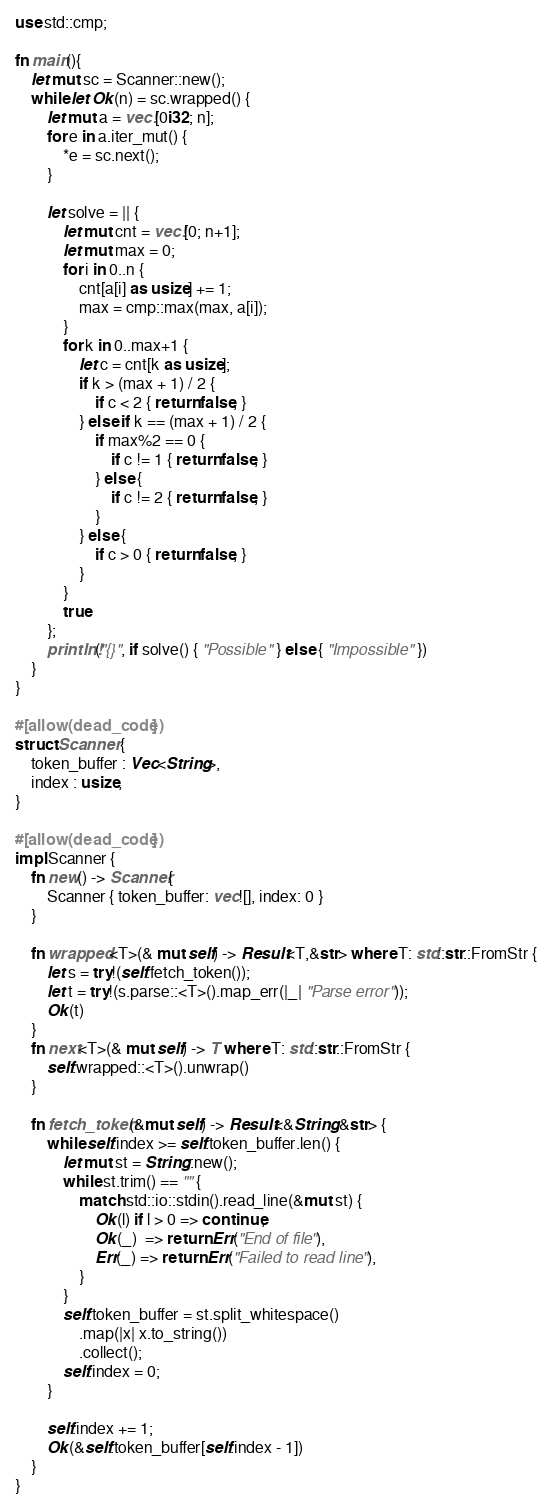<code> <loc_0><loc_0><loc_500><loc_500><_Rust_>use std::cmp;

fn main(){
    let mut sc = Scanner::new();
    while let Ok(n) = sc.wrapped() {
        let mut a = vec![0i32; n];
        for e in a.iter_mut() {
            *e = sc.next();
        }

        let solve = || {
            let mut cnt = vec![0; n+1];
            let mut max = 0;
            for i in 0..n {
                cnt[a[i] as usize] += 1;
                max = cmp::max(max, a[i]);
            }
            for k in 0..max+1 {
                let c = cnt[k as usize];
                if k > (max + 1) / 2 {
                    if c < 2 { return false; }
                } else if k == (max + 1) / 2 {
                    if max%2 == 0 {
                        if c != 1 { return false; }
                    } else {
                        if c != 2 { return false; }
                    }
                } else {
                    if c > 0 { return false; }
                }
            }
            true
        };
        println!("{}", if solve() { "Possible" } else { "Impossible" })
    }
}

#[allow(dead_code)]
struct Scanner {
    token_buffer : Vec<String>,
    index : usize,
}

#[allow(dead_code)]
impl Scanner {
    fn new() -> Scanner{
        Scanner { token_buffer: vec![], index: 0 }
    }

    fn wrapped<T>(& mut self) -> Result<T,&str> where T: std::str::FromStr {
        let s = try!(self.fetch_token());
        let t = try!(s.parse::<T>().map_err(|_| "Parse error"));
        Ok(t)
    }
    fn next<T>(& mut self) -> T where T: std::str::FromStr {
        self.wrapped::<T>().unwrap()
    }

    fn fetch_token(&mut self) -> Result<&String,&str> {
        while self.index >= self.token_buffer.len() {
            let mut st = String::new();
            while st.trim() == "" {
                match std::io::stdin().read_line(&mut st) {
                    Ok(l) if l > 0 => continue,
                    Ok(_)  => return Err("End of file"),
                    Err(_) => return Err("Failed to read line"),
                }
            }
            self.token_buffer = st.split_whitespace()
                .map(|x| x.to_string())
                .collect();
            self.index = 0;
        }

        self.index += 1;
        Ok(&self.token_buffer[self.index - 1])
    }
}
</code> 